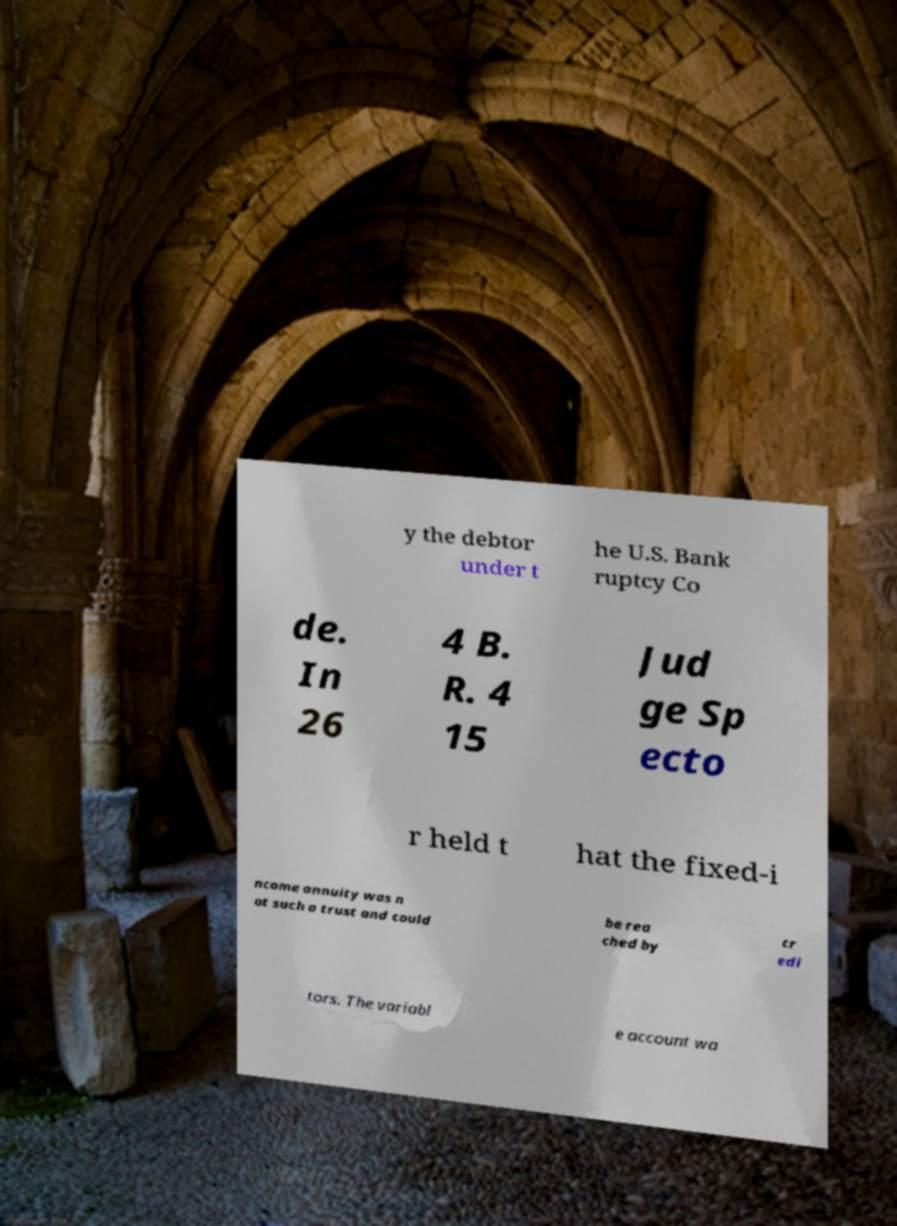Can you read and provide the text displayed in the image?This photo seems to have some interesting text. Can you extract and type it out for me? y the debtor under t he U.S. Bank ruptcy Co de. In 26 4 B. R. 4 15 Jud ge Sp ecto r held t hat the fixed-i ncome annuity was n ot such a trust and could be rea ched by cr edi tors. The variabl e account wa 